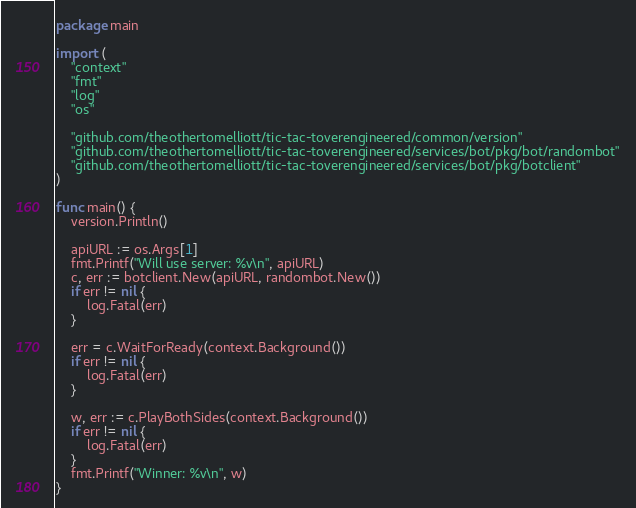<code> <loc_0><loc_0><loc_500><loc_500><_Go_>package main

import (
	"context"
	"fmt"
	"log"
	"os"

	"github.com/theothertomelliott/tic-tac-toverengineered/common/version"
	"github.com/theothertomelliott/tic-tac-toverengineered/services/bot/pkg/bot/randombot"
	"github.com/theothertomelliott/tic-tac-toverengineered/services/bot/pkg/botclient"
)

func main() {
	version.Println()

	apiURL := os.Args[1]
	fmt.Printf("Will use server: %v\n", apiURL)
	c, err := botclient.New(apiURL, randombot.New())
	if err != nil {
		log.Fatal(err)
	}

	err = c.WaitForReady(context.Background())
	if err != nil {
		log.Fatal(err)
	}

	w, err := c.PlayBothSides(context.Background())
	if err != nil {
		log.Fatal(err)
	}
	fmt.Printf("Winner: %v\n", w)
}
</code> 